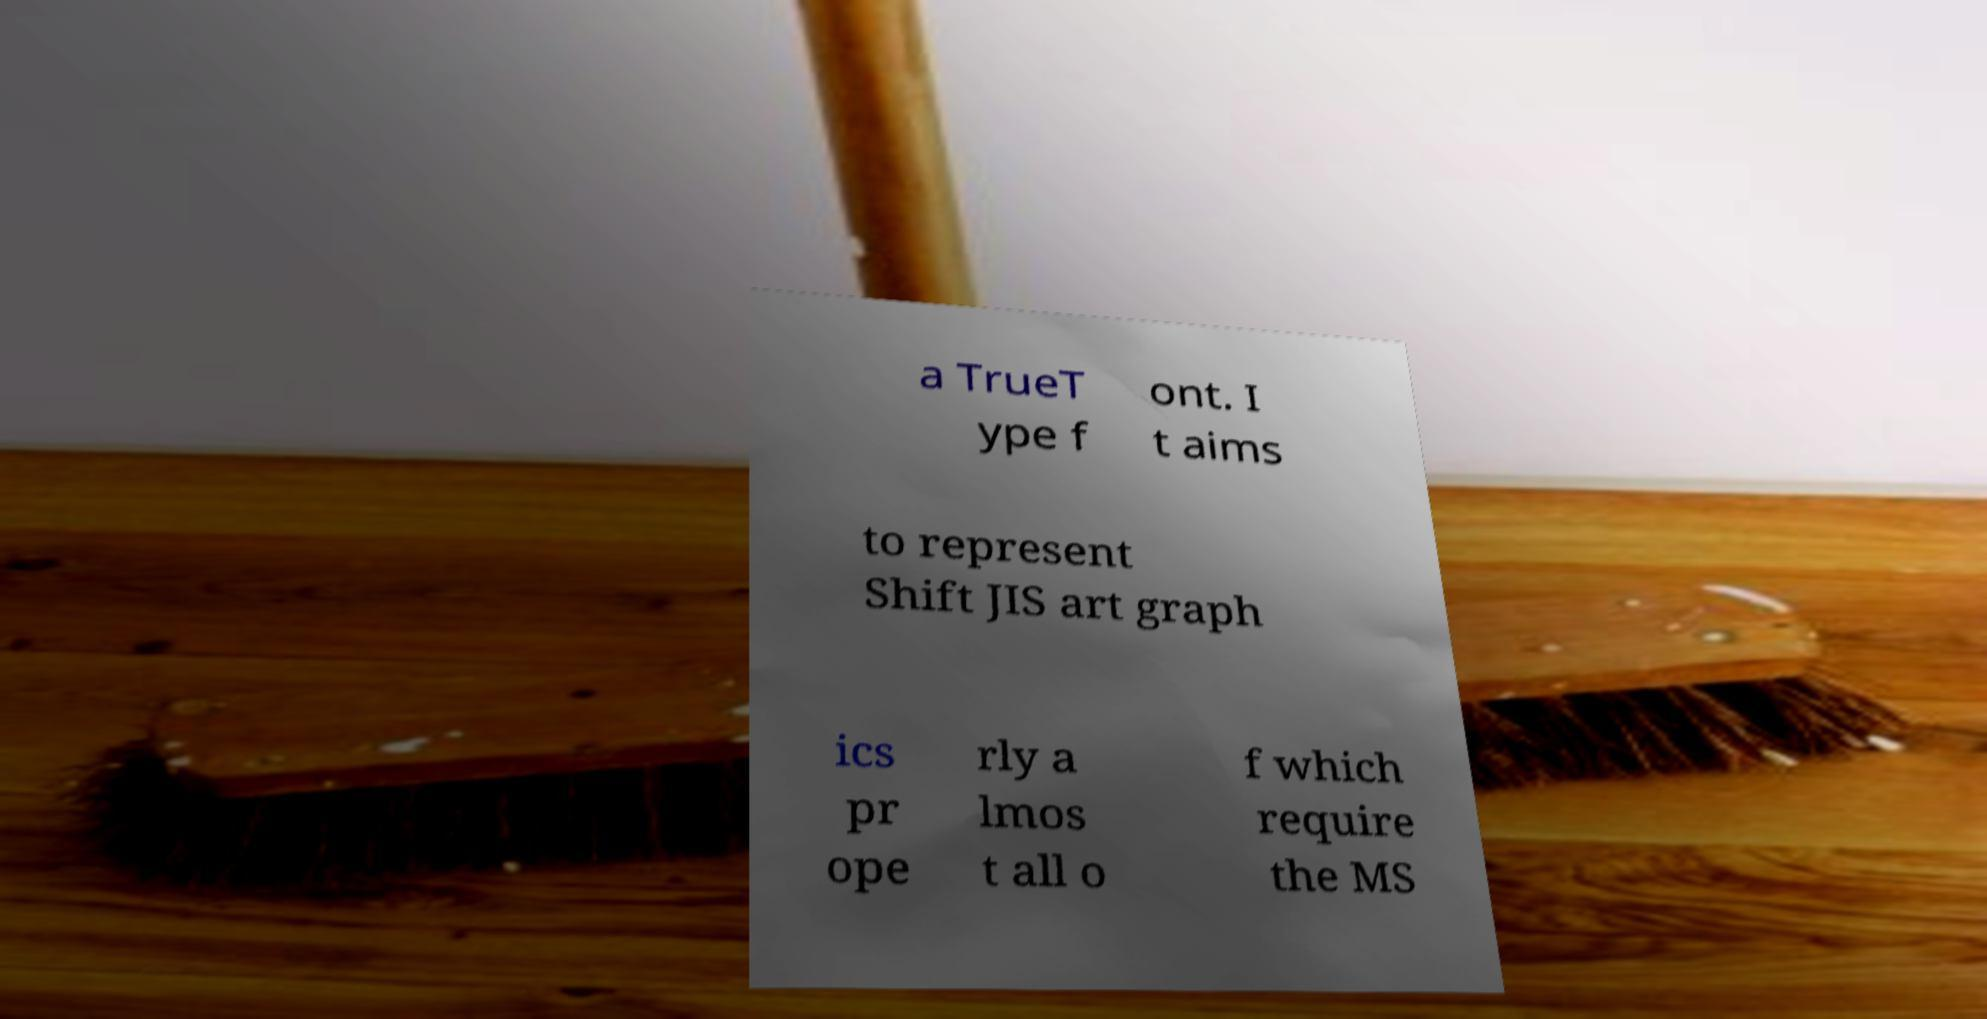There's text embedded in this image that I need extracted. Can you transcribe it verbatim? a TrueT ype f ont. I t aims to represent Shift JIS art graph ics pr ope rly a lmos t all o f which require the MS 